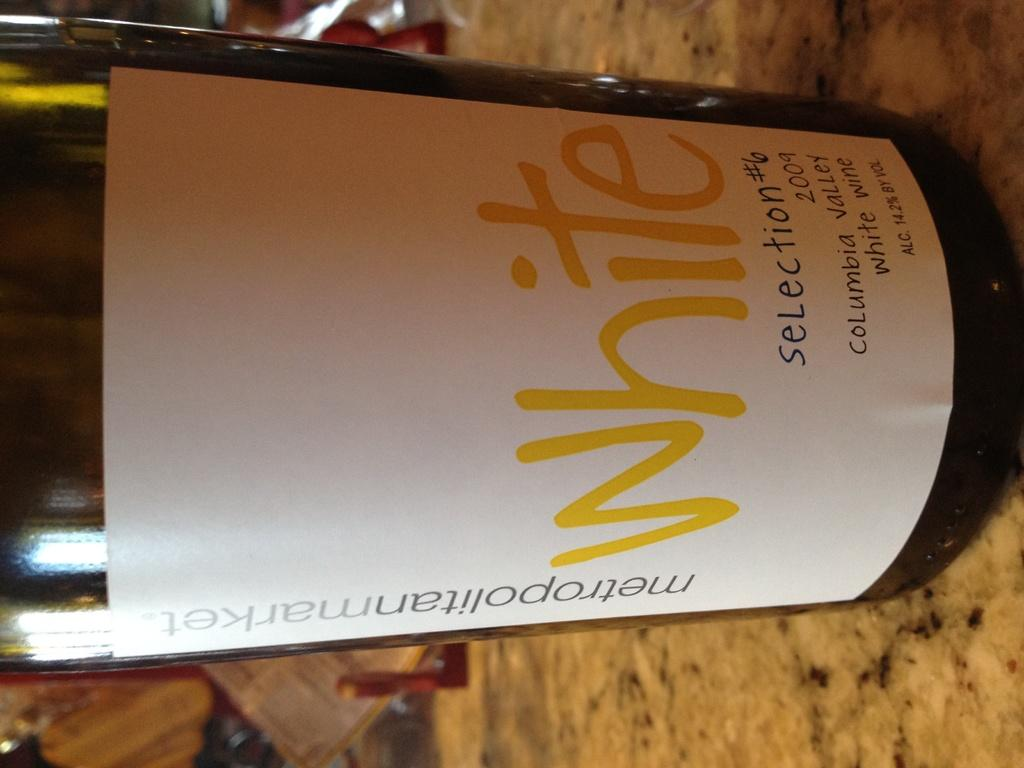<image>
Present a compact description of the photo's key features. A sideways picture of a wine bottle on a marble countertop, the label states "metropolitanmarket white selection#6 2009 Columbia Valley white wine Alc. 14.2% by vol 